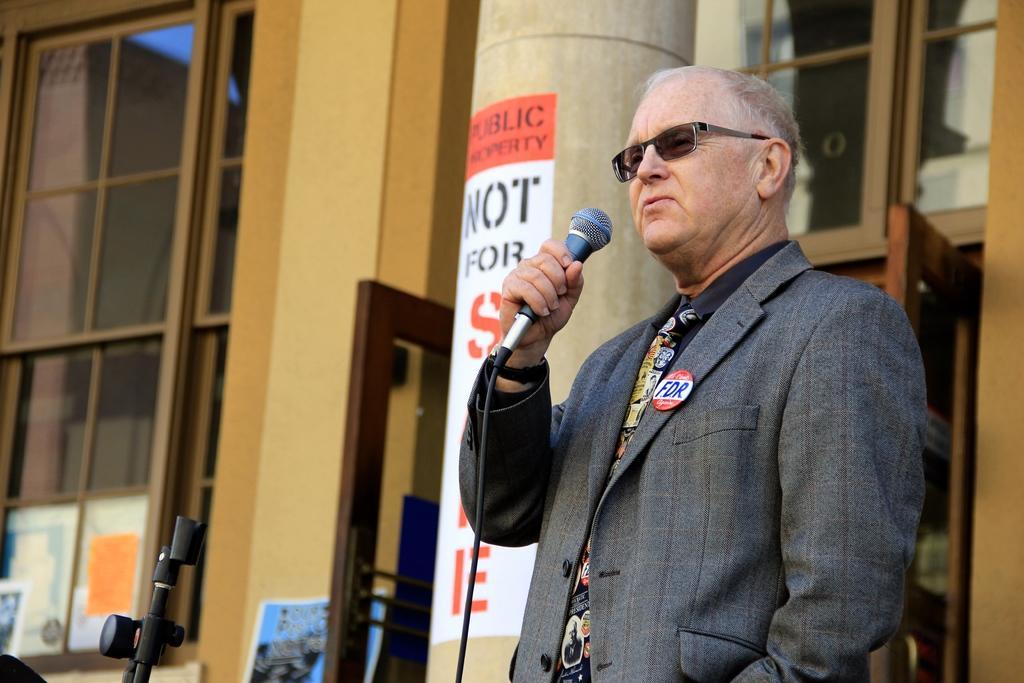Describe this image in one or two sentences. In this image there is a man who is standing and holding the mic in his hand. At the background there is a wall and a window. Beside the man there is a pillar to which there is a poster attached. 